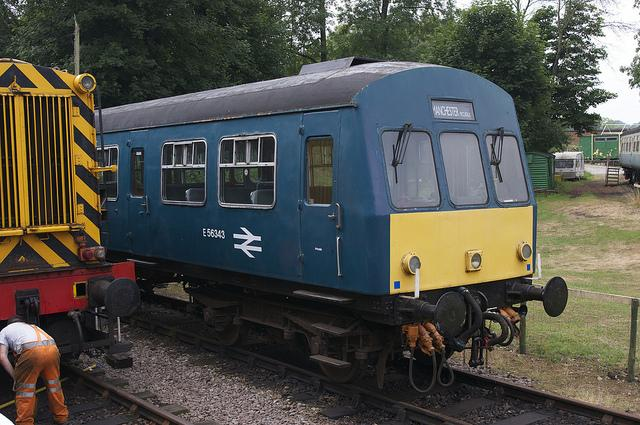What are the black circular pieces on the front of the train? Please explain your reasoning. bumpers. Round objects are on the front of a vehicle. bumpers are used on the front of vehicles. 